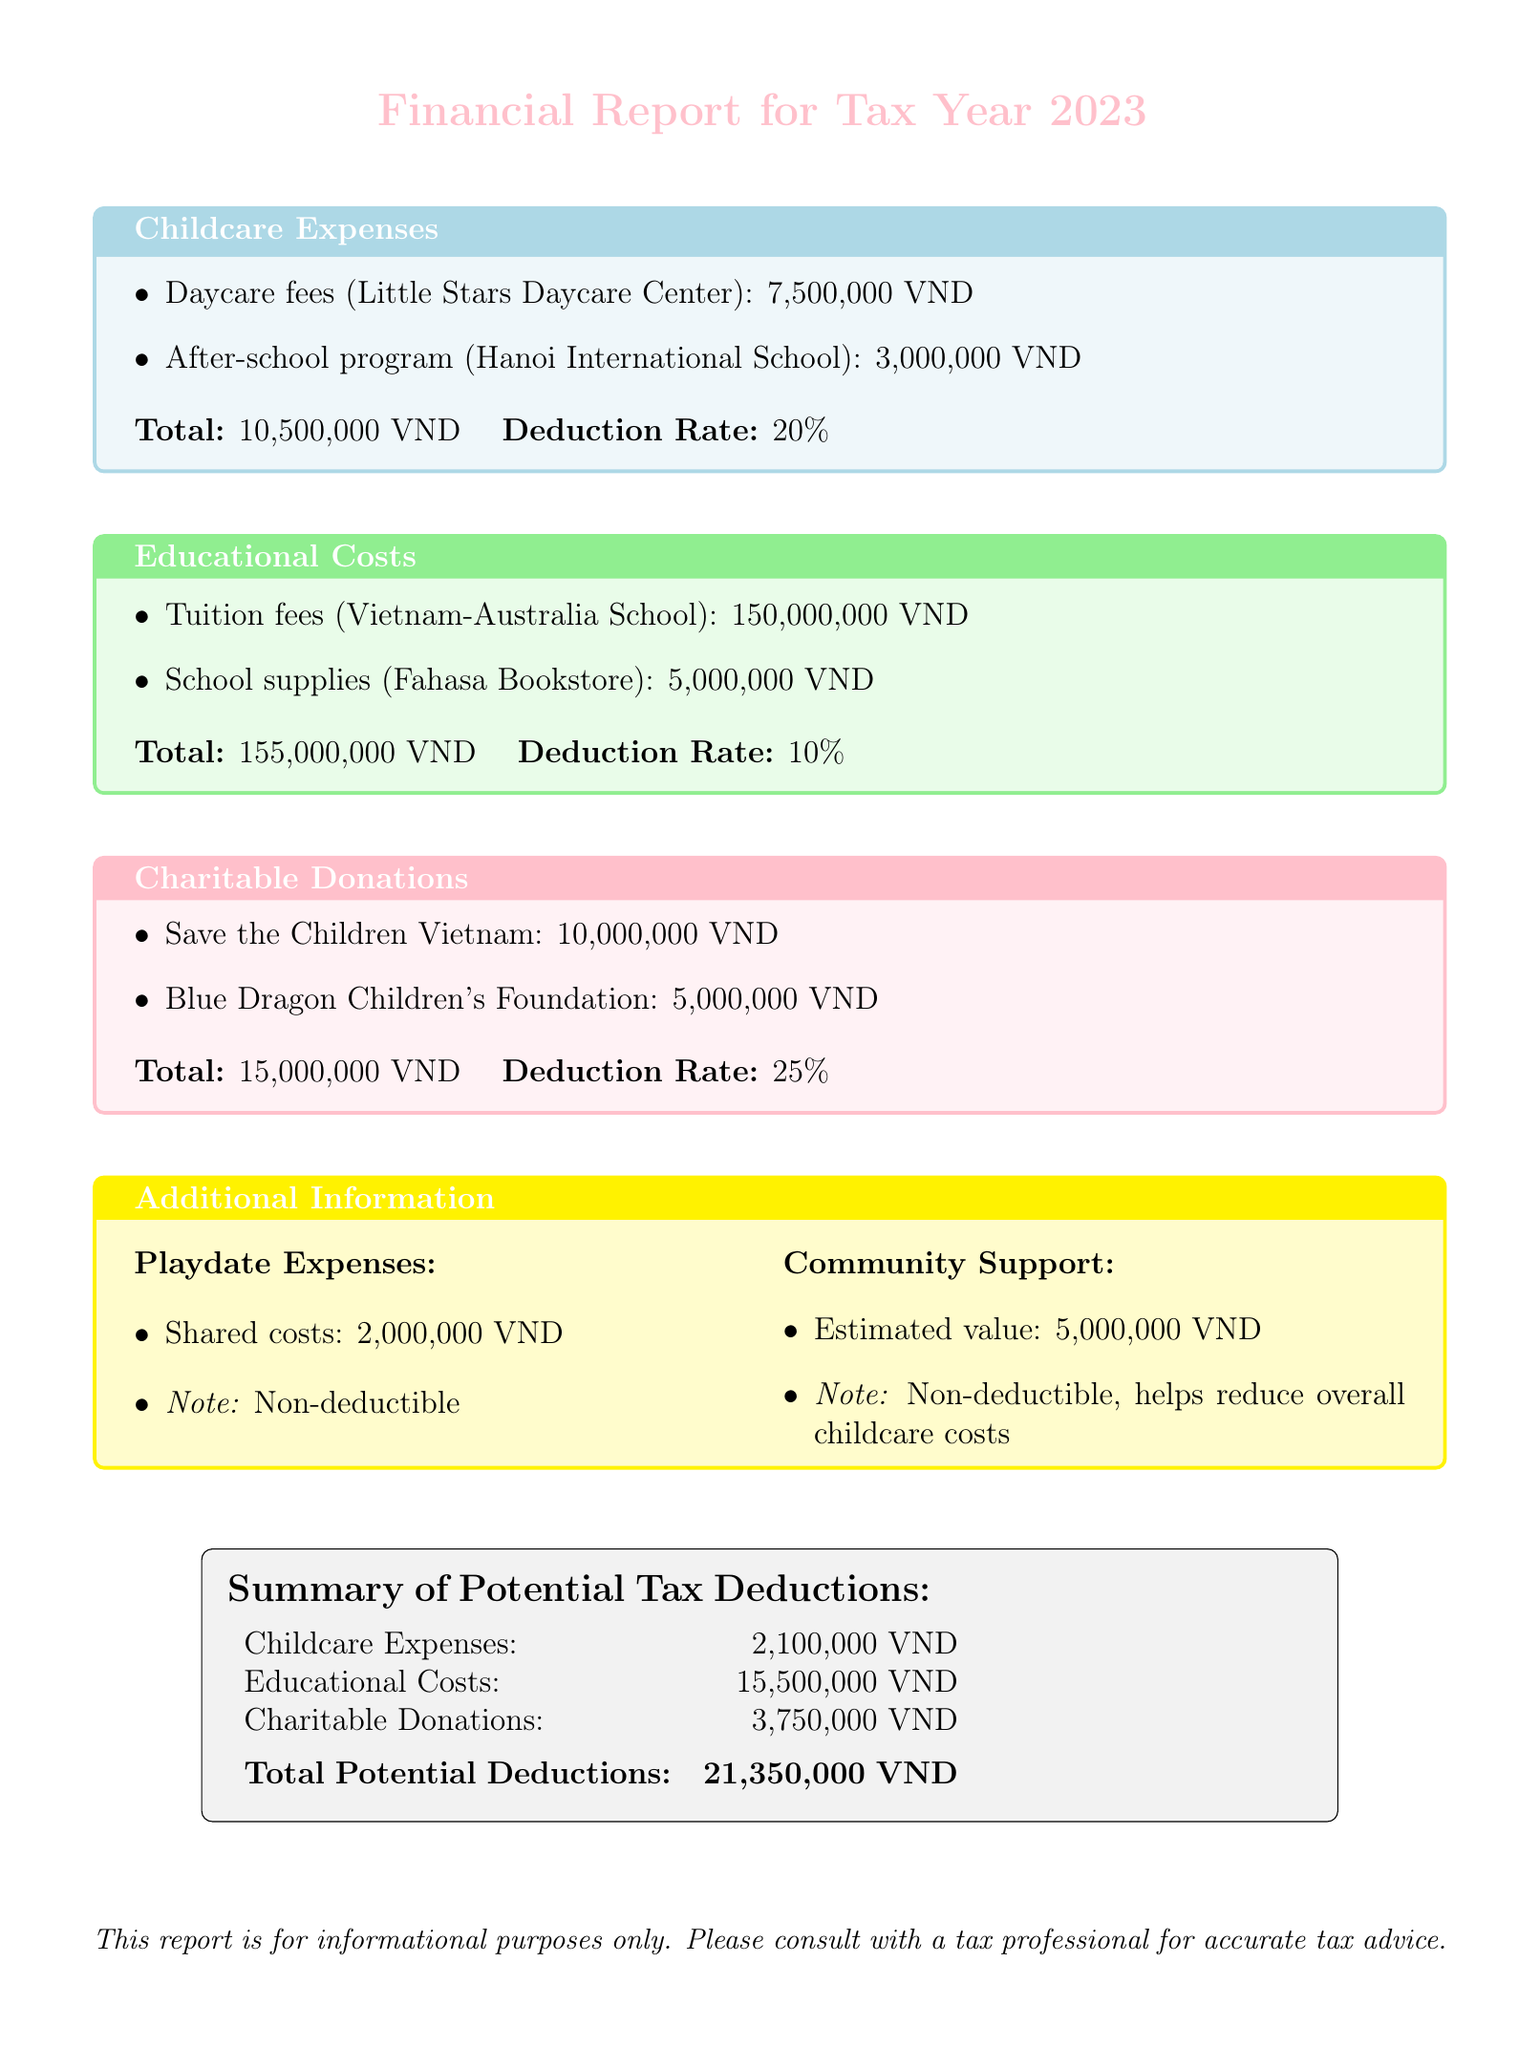What is the total amount spent on childcare expenses? The total amount for childcare expenses is the sum of daycare fees and after-school program fees: 7,500,000 VND + 3,000,000 VND = 10,500,000 VND.
Answer: 10,500,000 VND What is the deduction rate for educational costs? The deduction rate for educational costs is specified in the document under the educational costs section as 10%.
Answer: 10% What is the name of the organization receiving a charitable donation of 10,000,000 VND? The document lists Save the Children Vietnam as the organization associated with that donation amount.
Answer: Save the Children Vietnam What is the total potential deduction from childcare expenses? The documentation specifies the potential deduction from childcare expenses as calculated based on the total spent (10,500,000 VND) and the deduction rate (20%).
Answer: 2,100,000 VND Are playdate expenses deductible? According to the additional information section, playdate expenses are specifically noted as non-deductible.
Answer: No What is the total amount of charitable donations reported? The total for charitable donations can be calculated by adding together the amounts donated to each organization: 10,000,000 VND + 5,000,000 VND = 15,000,000 VND.
Answer: 15,000,000 VND How much was contributed to the Blue Dragon Children's Foundation? The document specifically states the donation amount made to the Blue Dragon Children's Foundation as 5,000,000 VND.
Answer: 5,000,000 VND What is the estimated value of community support? The estimated value of community support as mentioned in the document is 5,000,000 VND.
Answer: 5,000,000 VND What is the total potential deduction across all categories? The summary section totals the potential deductions for each category, adding up to 21,350,000 VND.
Answer: 21,350,000 VND 